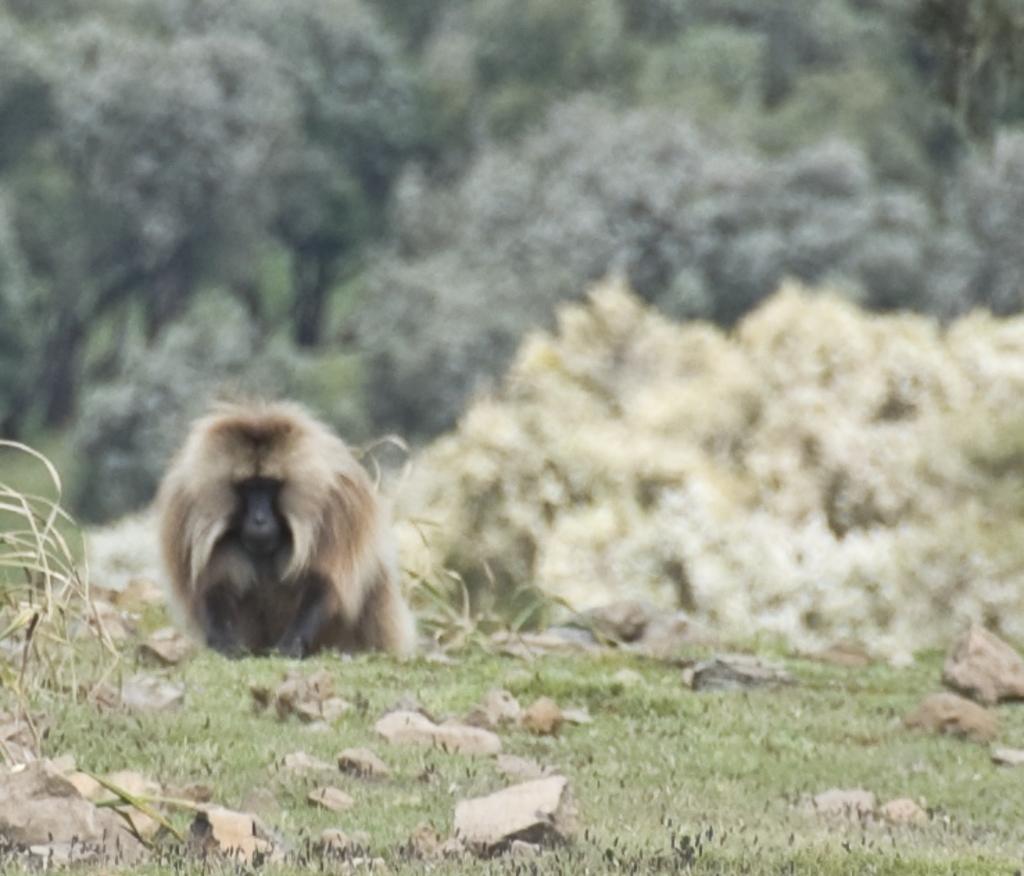In one or two sentences, can you explain what this image depicts? In this picture I can observe an animal on the left side. It is looking like a monkey. I can observe some grass on the ground. The background is blurred. 